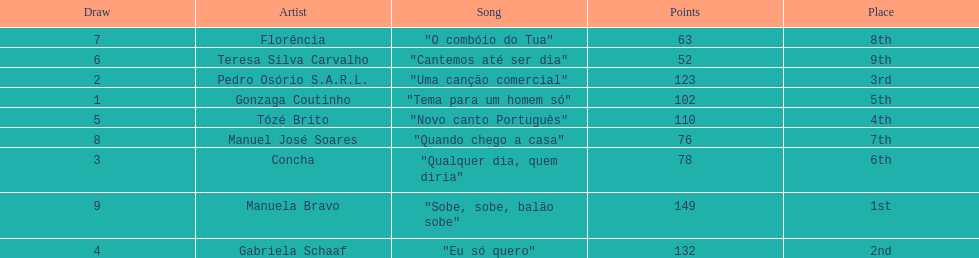Which artist came in last place? Teresa Silva Carvalho. 